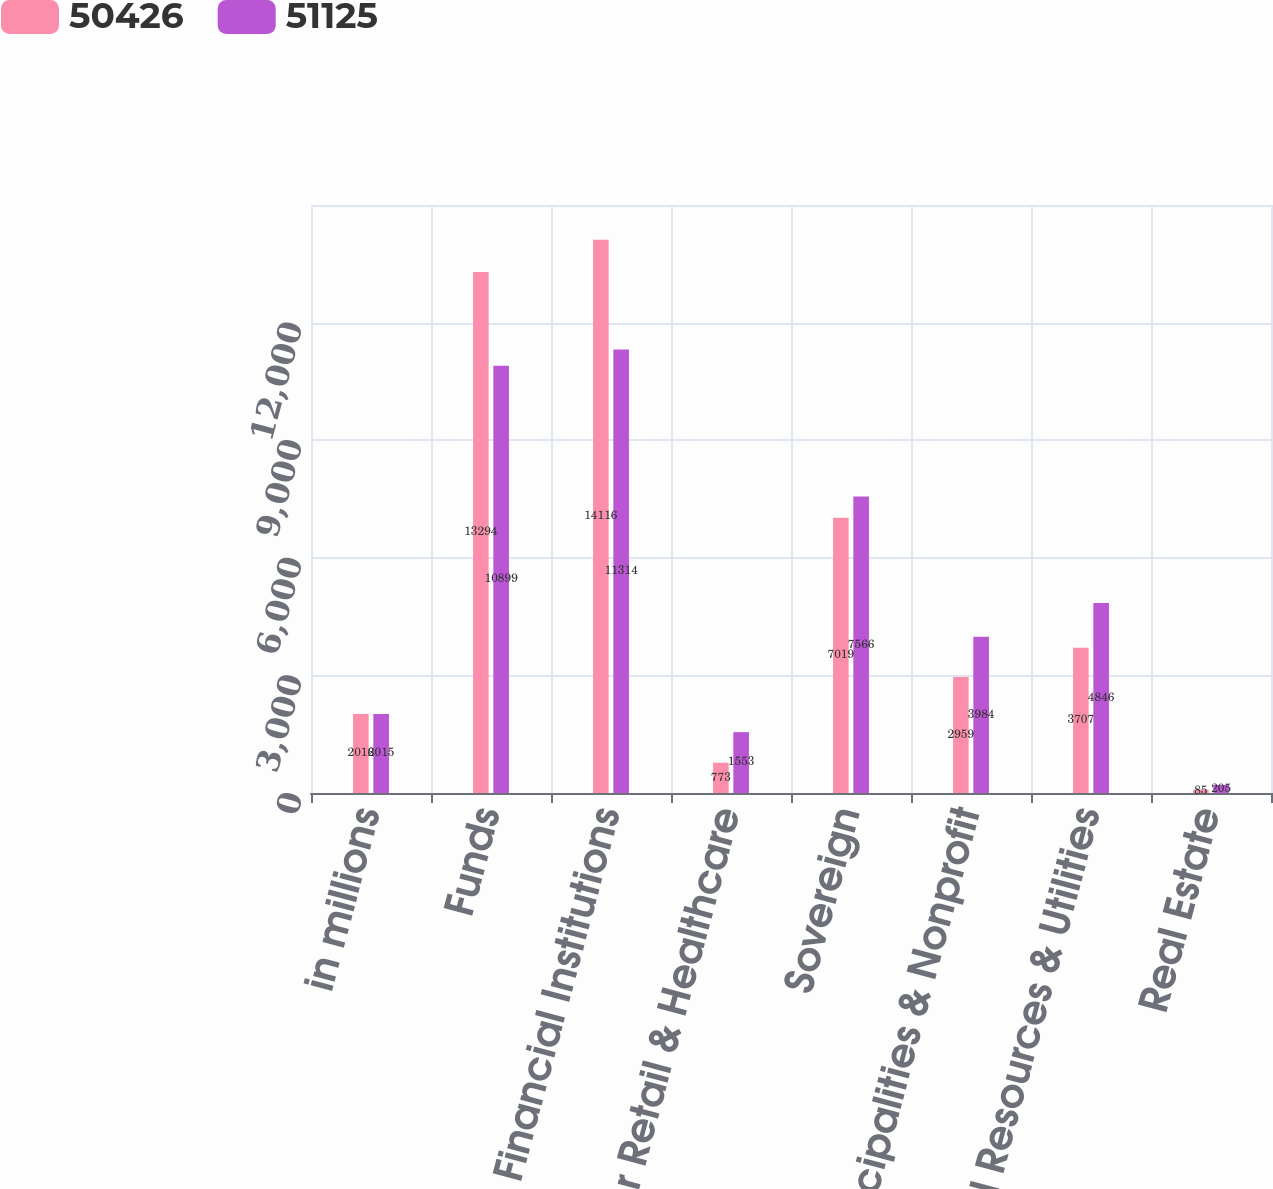Convert chart to OTSL. <chart><loc_0><loc_0><loc_500><loc_500><stacked_bar_chart><ecel><fcel>in millions<fcel>Funds<fcel>Financial Institutions<fcel>Consumer Retail & Healthcare<fcel>Sovereign<fcel>Municipalities & Nonprofit<fcel>Natural Resources & Utilities<fcel>Real Estate<nl><fcel>50426<fcel>2016<fcel>13294<fcel>14116<fcel>773<fcel>7019<fcel>2959<fcel>3707<fcel>85<nl><fcel>51125<fcel>2015<fcel>10899<fcel>11314<fcel>1553<fcel>7566<fcel>3984<fcel>4846<fcel>205<nl></chart> 